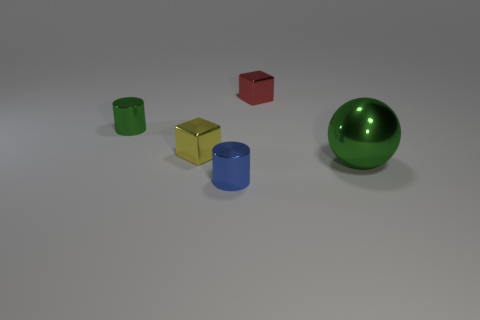There is a small thing that is the same color as the large metal object; what is it made of?
Offer a terse response. Metal. Is the number of green cylinders behind the tiny green metal thing greater than the number of small cyan shiny cylinders?
Your answer should be compact. No. The green sphere that is made of the same material as the yellow cube is what size?
Provide a short and direct response. Large. How many large things have the same color as the ball?
Make the answer very short. 0. There is a metal block in front of the tiny red object; is its color the same as the big metal sphere?
Your answer should be compact. No. Is the number of small yellow cubes that are behind the tiny green object the same as the number of small objects that are in front of the large ball?
Provide a succinct answer. No. Is there any other thing that is the same material as the yellow cube?
Ensure brevity in your answer.  Yes. What color is the tiny cylinder in front of the big metal object?
Your answer should be very brief. Blue. Are there an equal number of small red shiny objects to the left of the big green shiny object and small blue things?
Offer a terse response. Yes. How many other things are there of the same shape as the big thing?
Your response must be concise. 0. 